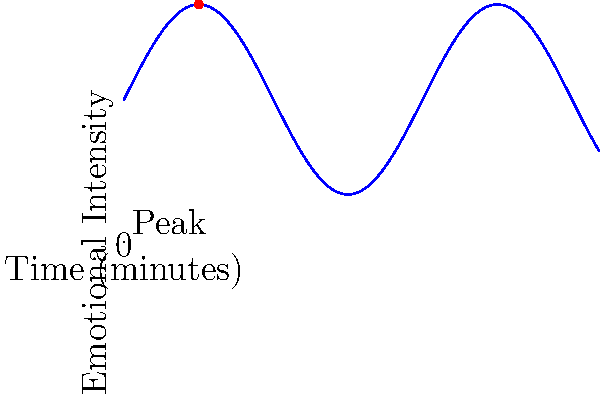In a study on emotional responses to movie scenes, you plot the emotional intensity of viewers over time during a 10-minute climactic scene. The emotional intensity $(y)$ as a function of time $(x)$ in minutes is given by the equation $y = 2\sin(x) + 3$. At what time does the emotional intensity reach its peak, and what is the maximum intensity value? To find the peak emotional intensity and its corresponding time:

1) The function $y = 2\sin(x) + 3$ is a sine wave with amplitude 2, vertically shifted by 3 units.

2) The peak of a sine wave occurs at $x = \frac{\pi}{2} + 2\pi n$, where $n$ is any integer.

3) Since we're only considering the first 10 minutes, the first peak occurs at $x = \frac{\pi}{2} \approx 1.57$ minutes.

4) To find the maximum intensity, we substitute this x-value into the equation:

   $y = 2\sin(\frac{\pi}{2}) + 3$
   $y = 2(1) + 3 = 5$

5) Therefore, the emotional intensity reaches its peak at approximately 1.57 minutes, with a maximum value of 5.

This analysis helps understand how quickly viewers' emotions intensify and the magnitude of their peak response, which is crucial for studying the impact of movie scenes on emotional states.
Answer: $(\frac{\pi}{2}, 5)$ or approximately $(1.57, 5)$ 